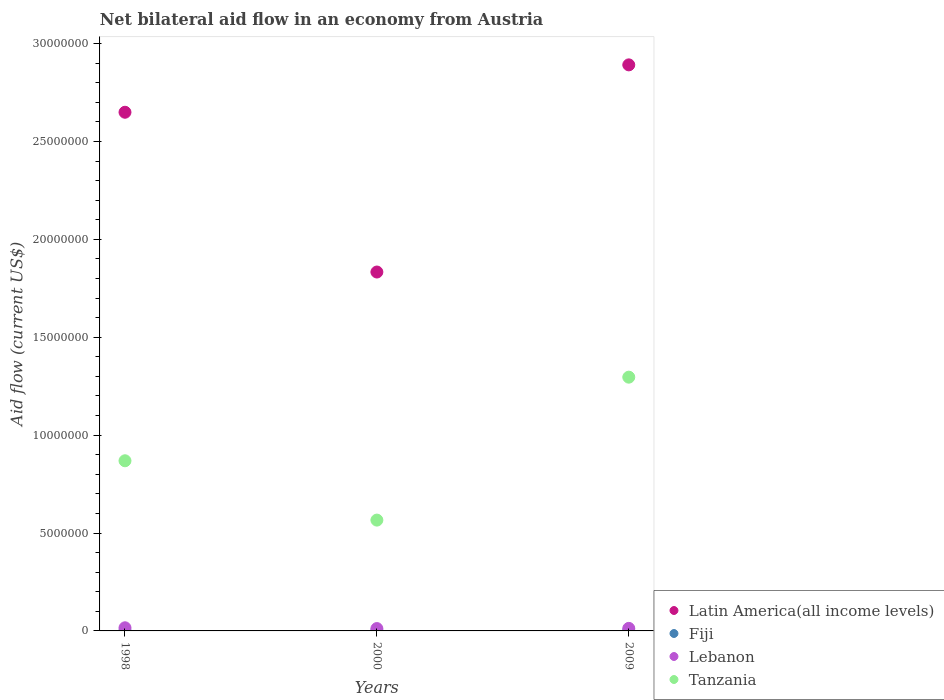What is the net bilateral aid flow in Latin America(all income levels) in 2009?
Make the answer very short. 2.89e+07. Across all years, what is the maximum net bilateral aid flow in Latin America(all income levels)?
Give a very brief answer. 2.89e+07. Across all years, what is the minimum net bilateral aid flow in Lebanon?
Provide a succinct answer. 1.20e+05. In which year was the net bilateral aid flow in Latin America(all income levels) maximum?
Provide a succinct answer. 2009. In which year was the net bilateral aid flow in Latin America(all income levels) minimum?
Offer a very short reply. 2000. What is the difference between the net bilateral aid flow in Latin America(all income levels) in 2000 and that in 2009?
Offer a terse response. -1.06e+07. What is the difference between the net bilateral aid flow in Fiji in 2000 and the net bilateral aid flow in Tanzania in 2009?
Your answer should be very brief. -1.30e+07. What is the average net bilateral aid flow in Tanzania per year?
Give a very brief answer. 9.10e+06. In the year 2009, what is the difference between the net bilateral aid flow in Lebanon and net bilateral aid flow in Latin America(all income levels)?
Keep it short and to the point. -2.88e+07. In how many years, is the net bilateral aid flow in Fiji greater than 9000000 US$?
Offer a terse response. 0. What is the ratio of the net bilateral aid flow in Fiji in 1998 to that in 2009?
Offer a very short reply. 0.5. Is the difference between the net bilateral aid flow in Lebanon in 1998 and 2009 greater than the difference between the net bilateral aid flow in Latin America(all income levels) in 1998 and 2009?
Make the answer very short. Yes. What is the difference between the highest and the second highest net bilateral aid flow in Tanzania?
Make the answer very short. 4.27e+06. What is the difference between the highest and the lowest net bilateral aid flow in Fiji?
Offer a terse response. 10000. In how many years, is the net bilateral aid flow in Tanzania greater than the average net bilateral aid flow in Tanzania taken over all years?
Ensure brevity in your answer.  1. Is it the case that in every year, the sum of the net bilateral aid flow in Tanzania and net bilateral aid flow in Lebanon  is greater than the sum of net bilateral aid flow in Fiji and net bilateral aid flow in Latin America(all income levels)?
Your response must be concise. No. Is it the case that in every year, the sum of the net bilateral aid flow in Tanzania and net bilateral aid flow in Latin America(all income levels)  is greater than the net bilateral aid flow in Lebanon?
Offer a very short reply. Yes. Does the graph contain any zero values?
Your response must be concise. No. What is the title of the graph?
Make the answer very short. Net bilateral aid flow in an economy from Austria. What is the Aid flow (current US$) of Latin America(all income levels) in 1998?
Keep it short and to the point. 2.65e+07. What is the Aid flow (current US$) of Fiji in 1998?
Your answer should be compact. 10000. What is the Aid flow (current US$) of Lebanon in 1998?
Provide a short and direct response. 1.60e+05. What is the Aid flow (current US$) of Tanzania in 1998?
Give a very brief answer. 8.69e+06. What is the Aid flow (current US$) in Latin America(all income levels) in 2000?
Provide a short and direct response. 1.83e+07. What is the Aid flow (current US$) of Lebanon in 2000?
Offer a very short reply. 1.20e+05. What is the Aid flow (current US$) in Tanzania in 2000?
Offer a very short reply. 5.66e+06. What is the Aid flow (current US$) in Latin America(all income levels) in 2009?
Offer a terse response. 2.89e+07. What is the Aid flow (current US$) of Tanzania in 2009?
Offer a terse response. 1.30e+07. Across all years, what is the maximum Aid flow (current US$) in Latin America(all income levels)?
Ensure brevity in your answer.  2.89e+07. Across all years, what is the maximum Aid flow (current US$) of Lebanon?
Keep it short and to the point. 1.60e+05. Across all years, what is the maximum Aid flow (current US$) of Tanzania?
Ensure brevity in your answer.  1.30e+07. Across all years, what is the minimum Aid flow (current US$) in Latin America(all income levels)?
Provide a short and direct response. 1.83e+07. Across all years, what is the minimum Aid flow (current US$) in Lebanon?
Your response must be concise. 1.20e+05. Across all years, what is the minimum Aid flow (current US$) in Tanzania?
Provide a succinct answer. 5.66e+06. What is the total Aid flow (current US$) in Latin America(all income levels) in the graph?
Your answer should be compact. 7.37e+07. What is the total Aid flow (current US$) in Tanzania in the graph?
Ensure brevity in your answer.  2.73e+07. What is the difference between the Aid flow (current US$) in Latin America(all income levels) in 1998 and that in 2000?
Keep it short and to the point. 8.16e+06. What is the difference between the Aid flow (current US$) of Tanzania in 1998 and that in 2000?
Your answer should be compact. 3.03e+06. What is the difference between the Aid flow (current US$) in Latin America(all income levels) in 1998 and that in 2009?
Keep it short and to the point. -2.42e+06. What is the difference between the Aid flow (current US$) of Fiji in 1998 and that in 2009?
Your response must be concise. -10000. What is the difference between the Aid flow (current US$) of Tanzania in 1998 and that in 2009?
Give a very brief answer. -4.27e+06. What is the difference between the Aid flow (current US$) in Latin America(all income levels) in 2000 and that in 2009?
Your response must be concise. -1.06e+07. What is the difference between the Aid flow (current US$) in Lebanon in 2000 and that in 2009?
Provide a succinct answer. -10000. What is the difference between the Aid flow (current US$) in Tanzania in 2000 and that in 2009?
Your answer should be very brief. -7.30e+06. What is the difference between the Aid flow (current US$) in Latin America(all income levels) in 1998 and the Aid flow (current US$) in Fiji in 2000?
Your answer should be compact. 2.65e+07. What is the difference between the Aid flow (current US$) of Latin America(all income levels) in 1998 and the Aid flow (current US$) of Lebanon in 2000?
Your response must be concise. 2.64e+07. What is the difference between the Aid flow (current US$) in Latin America(all income levels) in 1998 and the Aid flow (current US$) in Tanzania in 2000?
Provide a succinct answer. 2.08e+07. What is the difference between the Aid flow (current US$) of Fiji in 1998 and the Aid flow (current US$) of Lebanon in 2000?
Give a very brief answer. -1.10e+05. What is the difference between the Aid flow (current US$) in Fiji in 1998 and the Aid flow (current US$) in Tanzania in 2000?
Your answer should be very brief. -5.65e+06. What is the difference between the Aid flow (current US$) in Lebanon in 1998 and the Aid flow (current US$) in Tanzania in 2000?
Provide a short and direct response. -5.50e+06. What is the difference between the Aid flow (current US$) of Latin America(all income levels) in 1998 and the Aid flow (current US$) of Fiji in 2009?
Provide a short and direct response. 2.65e+07. What is the difference between the Aid flow (current US$) in Latin America(all income levels) in 1998 and the Aid flow (current US$) in Lebanon in 2009?
Your answer should be very brief. 2.64e+07. What is the difference between the Aid flow (current US$) of Latin America(all income levels) in 1998 and the Aid flow (current US$) of Tanzania in 2009?
Keep it short and to the point. 1.35e+07. What is the difference between the Aid flow (current US$) in Fiji in 1998 and the Aid flow (current US$) in Lebanon in 2009?
Your response must be concise. -1.20e+05. What is the difference between the Aid flow (current US$) in Fiji in 1998 and the Aid flow (current US$) in Tanzania in 2009?
Keep it short and to the point. -1.30e+07. What is the difference between the Aid flow (current US$) in Lebanon in 1998 and the Aid flow (current US$) in Tanzania in 2009?
Offer a very short reply. -1.28e+07. What is the difference between the Aid flow (current US$) in Latin America(all income levels) in 2000 and the Aid flow (current US$) in Fiji in 2009?
Make the answer very short. 1.83e+07. What is the difference between the Aid flow (current US$) of Latin America(all income levels) in 2000 and the Aid flow (current US$) of Lebanon in 2009?
Your response must be concise. 1.82e+07. What is the difference between the Aid flow (current US$) in Latin America(all income levels) in 2000 and the Aid flow (current US$) in Tanzania in 2009?
Give a very brief answer. 5.37e+06. What is the difference between the Aid flow (current US$) in Fiji in 2000 and the Aid flow (current US$) in Lebanon in 2009?
Your response must be concise. -1.20e+05. What is the difference between the Aid flow (current US$) in Fiji in 2000 and the Aid flow (current US$) in Tanzania in 2009?
Ensure brevity in your answer.  -1.30e+07. What is the difference between the Aid flow (current US$) of Lebanon in 2000 and the Aid flow (current US$) of Tanzania in 2009?
Give a very brief answer. -1.28e+07. What is the average Aid flow (current US$) of Latin America(all income levels) per year?
Give a very brief answer. 2.46e+07. What is the average Aid flow (current US$) of Fiji per year?
Ensure brevity in your answer.  1.33e+04. What is the average Aid flow (current US$) of Lebanon per year?
Give a very brief answer. 1.37e+05. What is the average Aid flow (current US$) of Tanzania per year?
Give a very brief answer. 9.10e+06. In the year 1998, what is the difference between the Aid flow (current US$) in Latin America(all income levels) and Aid flow (current US$) in Fiji?
Offer a very short reply. 2.65e+07. In the year 1998, what is the difference between the Aid flow (current US$) of Latin America(all income levels) and Aid flow (current US$) of Lebanon?
Offer a very short reply. 2.63e+07. In the year 1998, what is the difference between the Aid flow (current US$) in Latin America(all income levels) and Aid flow (current US$) in Tanzania?
Provide a succinct answer. 1.78e+07. In the year 1998, what is the difference between the Aid flow (current US$) of Fiji and Aid flow (current US$) of Tanzania?
Your answer should be very brief. -8.68e+06. In the year 1998, what is the difference between the Aid flow (current US$) of Lebanon and Aid flow (current US$) of Tanzania?
Your answer should be very brief. -8.53e+06. In the year 2000, what is the difference between the Aid flow (current US$) of Latin America(all income levels) and Aid flow (current US$) of Fiji?
Provide a short and direct response. 1.83e+07. In the year 2000, what is the difference between the Aid flow (current US$) in Latin America(all income levels) and Aid flow (current US$) in Lebanon?
Offer a very short reply. 1.82e+07. In the year 2000, what is the difference between the Aid flow (current US$) in Latin America(all income levels) and Aid flow (current US$) in Tanzania?
Offer a terse response. 1.27e+07. In the year 2000, what is the difference between the Aid flow (current US$) of Fiji and Aid flow (current US$) of Tanzania?
Your response must be concise. -5.65e+06. In the year 2000, what is the difference between the Aid flow (current US$) of Lebanon and Aid flow (current US$) of Tanzania?
Your response must be concise. -5.54e+06. In the year 2009, what is the difference between the Aid flow (current US$) of Latin America(all income levels) and Aid flow (current US$) of Fiji?
Give a very brief answer. 2.89e+07. In the year 2009, what is the difference between the Aid flow (current US$) of Latin America(all income levels) and Aid flow (current US$) of Lebanon?
Your answer should be very brief. 2.88e+07. In the year 2009, what is the difference between the Aid flow (current US$) in Latin America(all income levels) and Aid flow (current US$) in Tanzania?
Offer a terse response. 1.60e+07. In the year 2009, what is the difference between the Aid flow (current US$) in Fiji and Aid flow (current US$) in Lebanon?
Provide a short and direct response. -1.10e+05. In the year 2009, what is the difference between the Aid flow (current US$) of Fiji and Aid flow (current US$) of Tanzania?
Give a very brief answer. -1.29e+07. In the year 2009, what is the difference between the Aid flow (current US$) of Lebanon and Aid flow (current US$) of Tanzania?
Provide a succinct answer. -1.28e+07. What is the ratio of the Aid flow (current US$) in Latin America(all income levels) in 1998 to that in 2000?
Offer a terse response. 1.45. What is the ratio of the Aid flow (current US$) of Fiji in 1998 to that in 2000?
Provide a succinct answer. 1. What is the ratio of the Aid flow (current US$) of Tanzania in 1998 to that in 2000?
Your answer should be very brief. 1.54. What is the ratio of the Aid flow (current US$) of Latin America(all income levels) in 1998 to that in 2009?
Offer a terse response. 0.92. What is the ratio of the Aid flow (current US$) in Fiji in 1998 to that in 2009?
Keep it short and to the point. 0.5. What is the ratio of the Aid flow (current US$) in Lebanon in 1998 to that in 2009?
Your response must be concise. 1.23. What is the ratio of the Aid flow (current US$) in Tanzania in 1998 to that in 2009?
Offer a very short reply. 0.67. What is the ratio of the Aid flow (current US$) of Latin America(all income levels) in 2000 to that in 2009?
Your response must be concise. 0.63. What is the ratio of the Aid flow (current US$) in Lebanon in 2000 to that in 2009?
Ensure brevity in your answer.  0.92. What is the ratio of the Aid flow (current US$) in Tanzania in 2000 to that in 2009?
Offer a terse response. 0.44. What is the difference between the highest and the second highest Aid flow (current US$) of Latin America(all income levels)?
Provide a succinct answer. 2.42e+06. What is the difference between the highest and the second highest Aid flow (current US$) in Fiji?
Provide a short and direct response. 10000. What is the difference between the highest and the second highest Aid flow (current US$) in Tanzania?
Your answer should be very brief. 4.27e+06. What is the difference between the highest and the lowest Aid flow (current US$) of Latin America(all income levels)?
Your answer should be very brief. 1.06e+07. What is the difference between the highest and the lowest Aid flow (current US$) in Fiji?
Provide a short and direct response. 10000. What is the difference between the highest and the lowest Aid flow (current US$) of Tanzania?
Your answer should be very brief. 7.30e+06. 